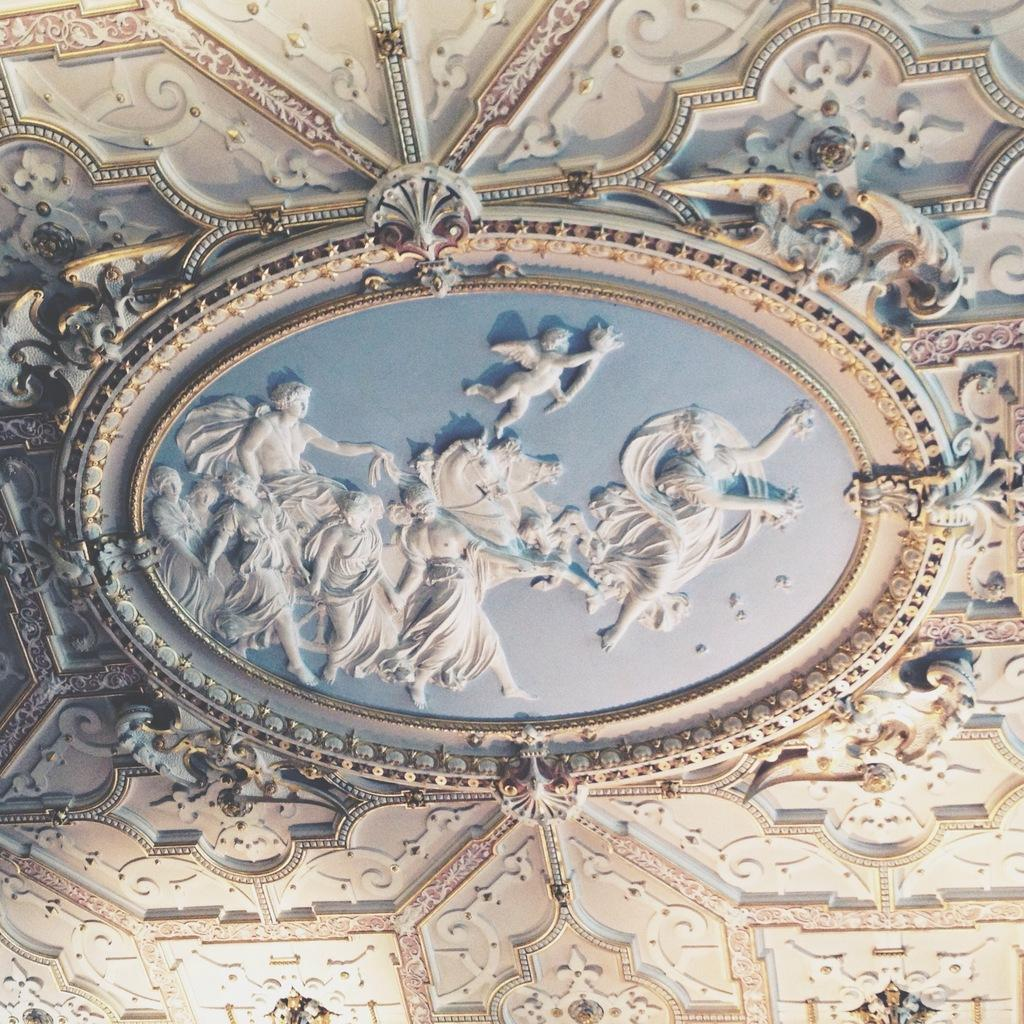What type of designs can be seen in the image? There are carved designs in the image. Where are the carved designs located? on? What type of dinosaurs can be seen in the aftermath of the image? There are no dinosaurs present in the image, and the term "aftermath" does not apply to the context of the image. 